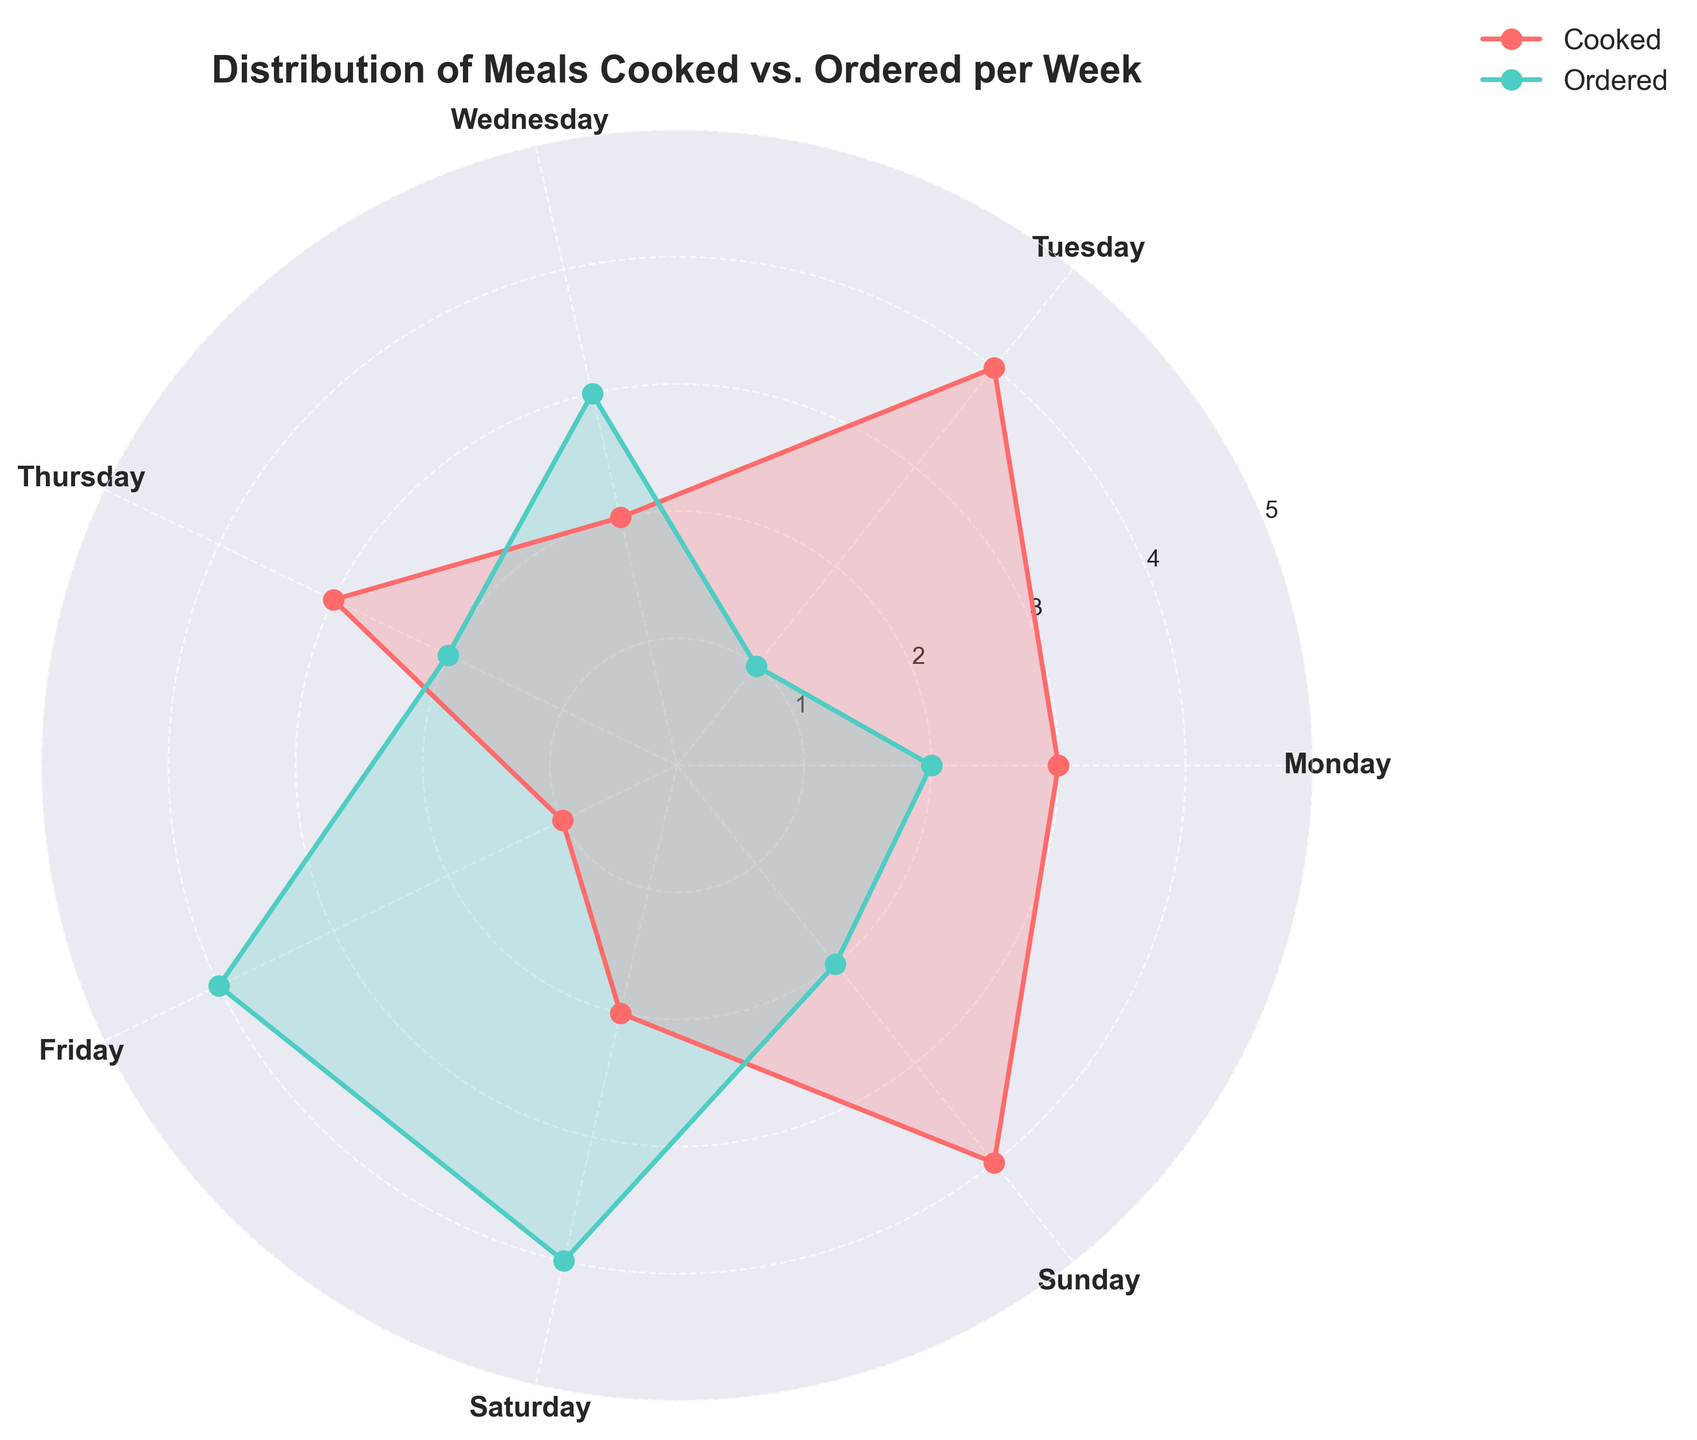What is the title of the figure? The title is usually located at the top of the figure and provides an overview of what the chart is about. In this case, it indicates that the figure shows the "Distribution of Meals Cooked vs. Ordered per Week."
Answer: Distribution of Meals Cooked vs. Ordered per Week How many meals were cooked on Monday? By looking at the red line (or filled area) corresponding to Monday on the figure, we can see the value represented, which is 3 meals.
Answer: 3 Which day had the most ordered meals? By examining the green line (or filled area) across the days, the highest point occurs on Friday and Saturday. Both days show 4 ordered meals.
Answer: Friday and Saturday What is the average number of cooked meals from Monday to Sunday? To find the average, sum the cooked meals for each day (3+4+2+3+1+2+4) and divide by the number of days (7). That gives (3+4+2+3+1+2+4)=19, 19/7≈2.71
Answer: 2.71 How do the number of cooked meals on Thursday compare to those ordered on the same day? Check the values for cooked and ordered meals on Thursday from the red and green representations respectively. Cooked meals are 3 and ordered meals are 2. 3 cooked meals are greater than 2 ordered meals.
Answer: Cooked > Ordered Which day shows the least number of cooked meals? By identifying the lowest point in the red line (or filled area), we notice that Friday has the least number of cooked meals, with a value of 1.
Answer: Friday What is the total number of ordered meals for the week? Add up the ordered meals for each day: (2+1+3+2+4+4+2). The total is (2+1+3+2+4+4+2)=18
Answer: 18 Do any days have an equal number of cooked and ordered meals? Compare the values for cooked and ordered meals across each day. Wednesday shows 2 cooked meals and 3 ordered meals; no other days have matching values. Therefore, no day has an equal number.
Answer: No What is the ratio of cooked to ordered meals on Sunday? Look at the values for cooked and ordered meals on Sunday. Cooked meals are 4 and ordered meals are 2. The ratio is calculated as 4:2 or simplified to 2:1.
Answer: 2:1 How does the pattern of cooked meals change throughout the week? Observing the red line (or filled area), note that the pattern starts at 3 on Monday, peaks slightly on Tuesday at 4, drops to 2 on Wednesday, remains stable at 3 on Thursday, dips to its lowest at 1 on Friday, rises to 2 on Saturday, and peaks again at 4 on Sunday. This indicates variability with higher values typically towards the start and end of the week.
Answer: Variable, with peaks at the start and end of the week 